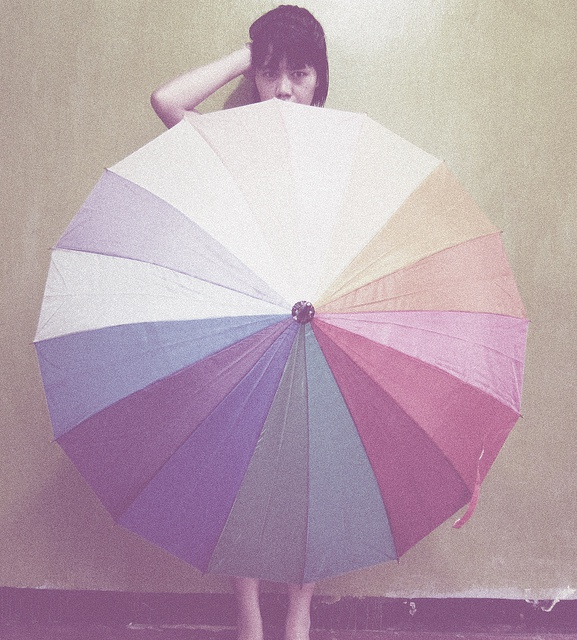Describe the objects in this image and their specific colors. I can see umbrella in darkgray, lightgray, violet, gray, and lightpink tones and people in darkgray, gray, lightgray, lightpink, and purple tones in this image. 